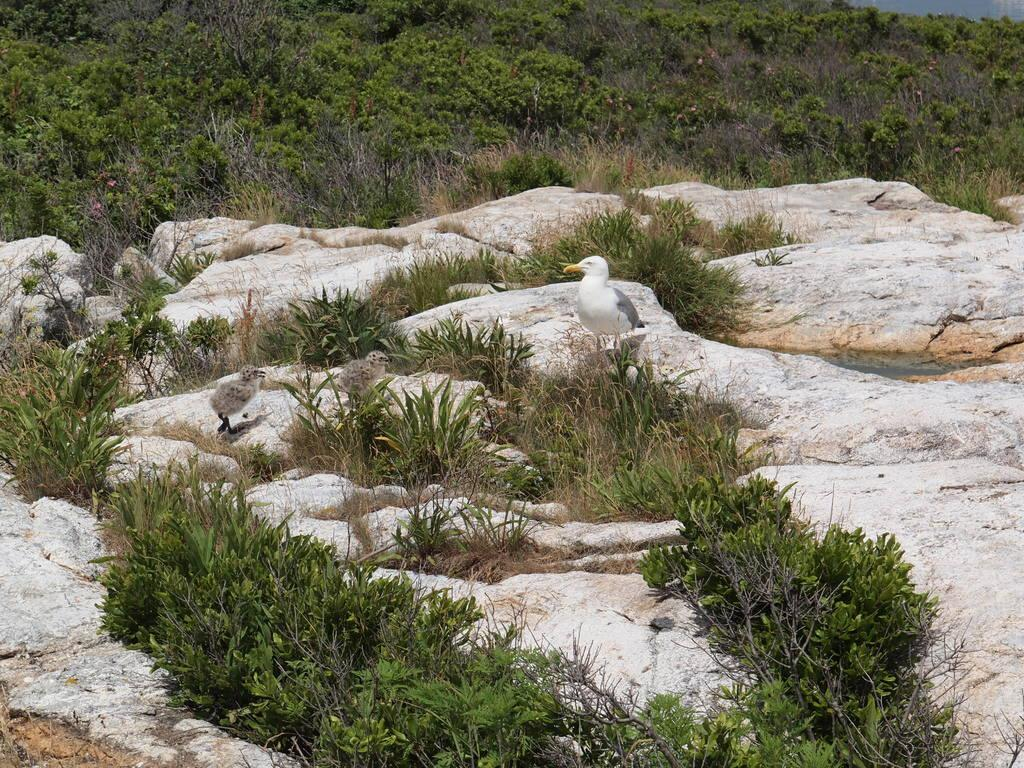What animals are present in the image? There are birds standing on the ground in the image. What is located on the rock in the image? There are plants on a rock in the image. What type of vegetation can be seen in the background of the image? There are trees visible in the background of the image. What type of zephyr can be seen blowing through the camp in the image? There is no camp or zephyr present in the image. 